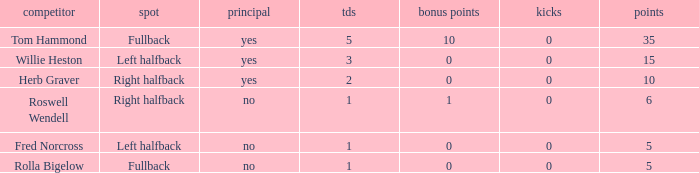What is the lowest number of field goals for a player with 3 touchdowns? 0.0. Write the full table. {'header': ['competitor', 'spot', 'principal', 'tds', 'bonus points', 'kicks', 'points'], 'rows': [['Tom Hammond', 'Fullback', 'yes', '5', '10', '0', '35'], ['Willie Heston', 'Left halfback', 'yes', '3', '0', '0', '15'], ['Herb Graver', 'Right halfback', 'yes', '2', '0', '0', '10'], ['Roswell Wendell', 'Right halfback', 'no', '1', '1', '0', '6'], ['Fred Norcross', 'Left halfback', 'no', '1', '0', '0', '5'], ['Rolla Bigelow', 'Fullback', 'no', '1', '0', '0', '5']]} 